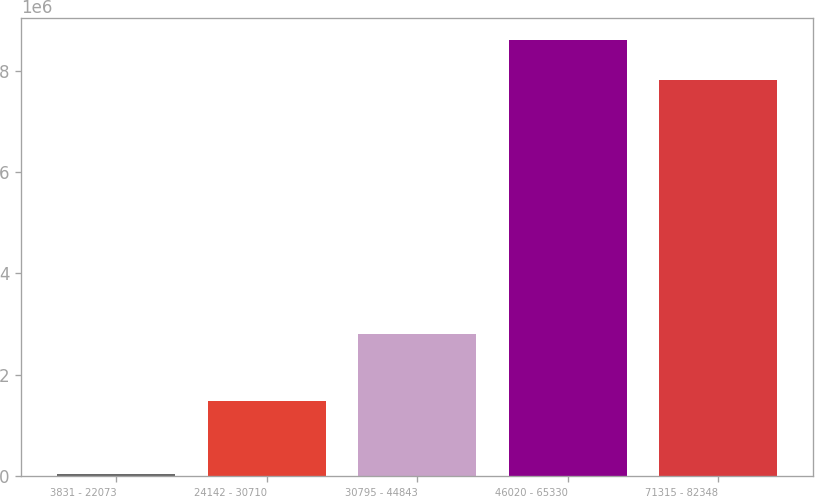Convert chart to OTSL. <chart><loc_0><loc_0><loc_500><loc_500><bar_chart><fcel>3831 - 22073<fcel>24142 - 30710<fcel>30795 - 44843<fcel>46020 - 65330<fcel>71315 - 82348<nl><fcel>32617<fcel>1.48155e+06<fcel>2.7998e+06<fcel>8.60585e+06<fcel>7.81781e+06<nl></chart> 